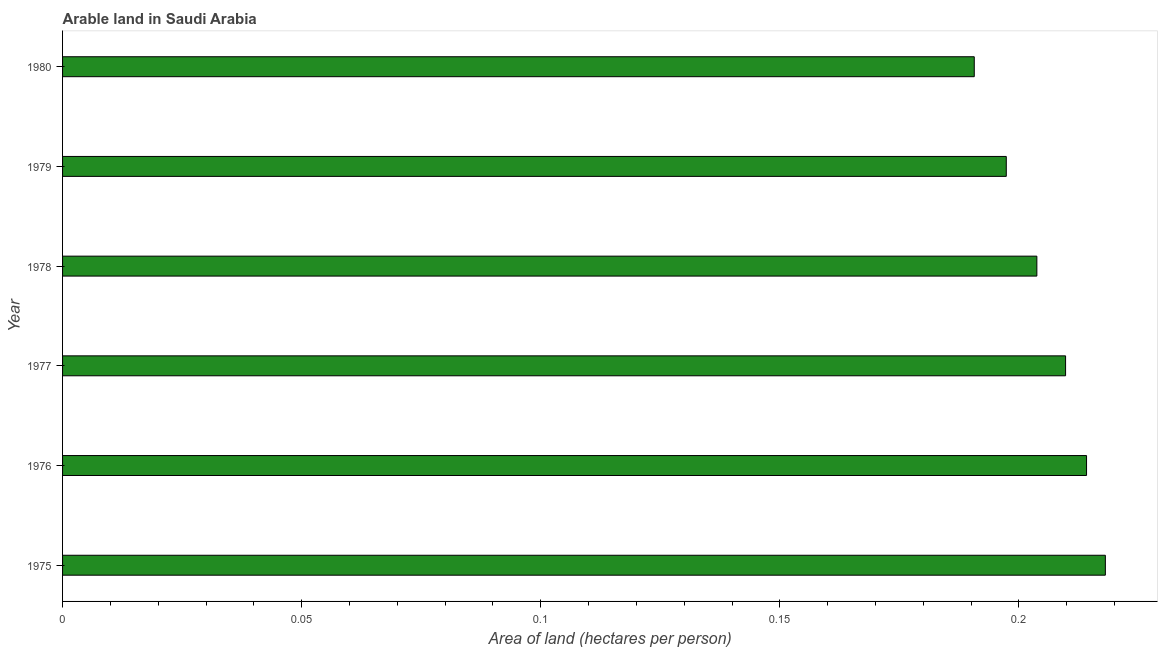Does the graph contain grids?
Offer a very short reply. No. What is the title of the graph?
Your answer should be compact. Arable land in Saudi Arabia. What is the label or title of the X-axis?
Offer a terse response. Area of land (hectares per person). What is the label or title of the Y-axis?
Your answer should be compact. Year. What is the area of arable land in 1978?
Give a very brief answer. 0.2. Across all years, what is the maximum area of arable land?
Your answer should be very brief. 0.22. Across all years, what is the minimum area of arable land?
Offer a terse response. 0.19. In which year was the area of arable land maximum?
Ensure brevity in your answer.  1975. What is the sum of the area of arable land?
Your answer should be very brief. 1.23. What is the average area of arable land per year?
Your response must be concise. 0.21. What is the median area of arable land?
Ensure brevity in your answer.  0.21. What is the ratio of the area of arable land in 1976 to that in 1979?
Your answer should be compact. 1.08. Is the area of arable land in 1975 less than that in 1980?
Offer a very short reply. No. Is the difference between the area of arable land in 1975 and 1980 greater than the difference between any two years?
Offer a terse response. Yes. What is the difference between the highest and the second highest area of arable land?
Keep it short and to the point. 0. What is the difference between the highest and the lowest area of arable land?
Offer a terse response. 0.03. In how many years, is the area of arable land greater than the average area of arable land taken over all years?
Keep it short and to the point. 3. What is the difference between two consecutive major ticks on the X-axis?
Provide a short and direct response. 0.05. Are the values on the major ticks of X-axis written in scientific E-notation?
Your answer should be compact. No. What is the Area of land (hectares per person) in 1975?
Provide a succinct answer. 0.22. What is the Area of land (hectares per person) in 1976?
Provide a succinct answer. 0.21. What is the Area of land (hectares per person) in 1977?
Provide a short and direct response. 0.21. What is the Area of land (hectares per person) in 1978?
Provide a short and direct response. 0.2. What is the Area of land (hectares per person) of 1979?
Offer a very short reply. 0.2. What is the Area of land (hectares per person) in 1980?
Your answer should be very brief. 0.19. What is the difference between the Area of land (hectares per person) in 1975 and 1976?
Offer a very short reply. 0. What is the difference between the Area of land (hectares per person) in 1975 and 1977?
Provide a short and direct response. 0.01. What is the difference between the Area of land (hectares per person) in 1975 and 1978?
Your answer should be very brief. 0.01. What is the difference between the Area of land (hectares per person) in 1975 and 1979?
Make the answer very short. 0.02. What is the difference between the Area of land (hectares per person) in 1975 and 1980?
Keep it short and to the point. 0.03. What is the difference between the Area of land (hectares per person) in 1976 and 1977?
Keep it short and to the point. 0. What is the difference between the Area of land (hectares per person) in 1976 and 1978?
Provide a succinct answer. 0.01. What is the difference between the Area of land (hectares per person) in 1976 and 1979?
Your answer should be compact. 0.02. What is the difference between the Area of land (hectares per person) in 1976 and 1980?
Keep it short and to the point. 0.02. What is the difference between the Area of land (hectares per person) in 1977 and 1978?
Your answer should be very brief. 0.01. What is the difference between the Area of land (hectares per person) in 1977 and 1979?
Offer a terse response. 0.01. What is the difference between the Area of land (hectares per person) in 1977 and 1980?
Give a very brief answer. 0.02. What is the difference between the Area of land (hectares per person) in 1978 and 1979?
Ensure brevity in your answer.  0.01. What is the difference between the Area of land (hectares per person) in 1978 and 1980?
Keep it short and to the point. 0.01. What is the difference between the Area of land (hectares per person) in 1979 and 1980?
Give a very brief answer. 0.01. What is the ratio of the Area of land (hectares per person) in 1975 to that in 1976?
Keep it short and to the point. 1.02. What is the ratio of the Area of land (hectares per person) in 1975 to that in 1977?
Your response must be concise. 1.04. What is the ratio of the Area of land (hectares per person) in 1975 to that in 1978?
Provide a short and direct response. 1.07. What is the ratio of the Area of land (hectares per person) in 1975 to that in 1979?
Make the answer very short. 1.1. What is the ratio of the Area of land (hectares per person) in 1975 to that in 1980?
Provide a short and direct response. 1.14. What is the ratio of the Area of land (hectares per person) in 1976 to that in 1978?
Keep it short and to the point. 1.05. What is the ratio of the Area of land (hectares per person) in 1976 to that in 1979?
Your answer should be very brief. 1.08. What is the ratio of the Area of land (hectares per person) in 1976 to that in 1980?
Keep it short and to the point. 1.12. What is the ratio of the Area of land (hectares per person) in 1977 to that in 1978?
Your answer should be compact. 1.03. What is the ratio of the Area of land (hectares per person) in 1977 to that in 1979?
Ensure brevity in your answer.  1.06. What is the ratio of the Area of land (hectares per person) in 1978 to that in 1979?
Give a very brief answer. 1.03. What is the ratio of the Area of land (hectares per person) in 1978 to that in 1980?
Your response must be concise. 1.07. What is the ratio of the Area of land (hectares per person) in 1979 to that in 1980?
Your answer should be compact. 1.03. 